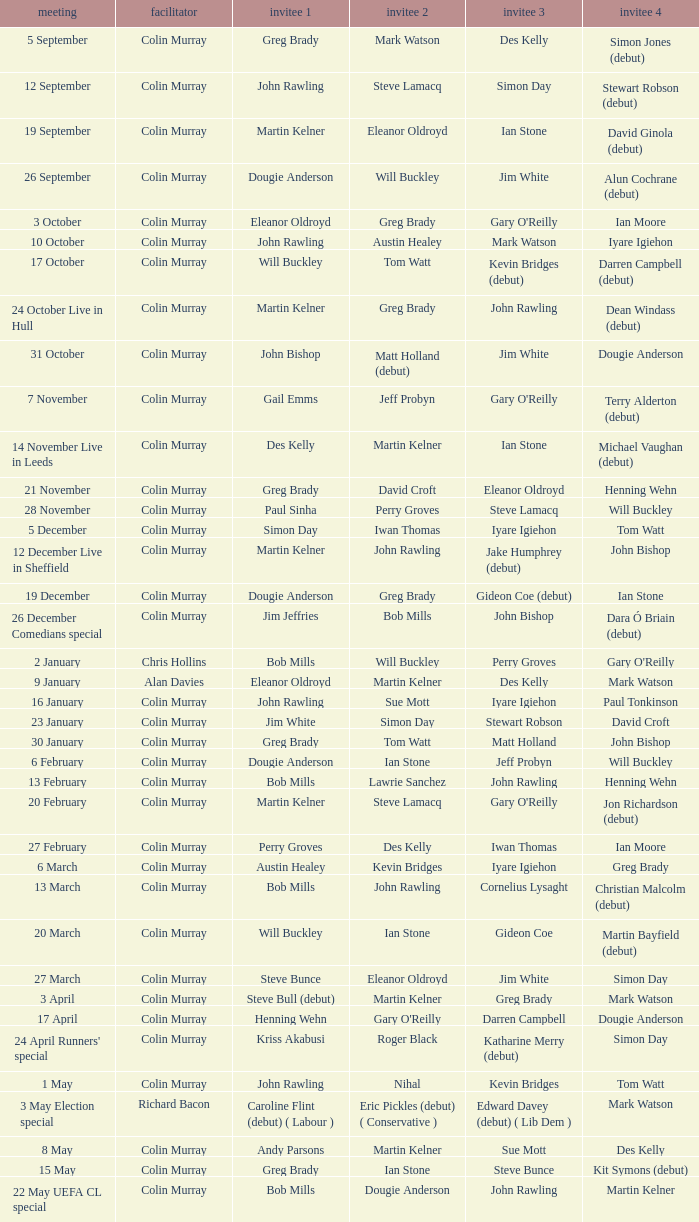Can you give me this table as a dict? {'header': ['meeting', 'facilitator', 'invitee 1', 'invitee 2', 'invitee 3', 'invitee 4'], 'rows': [['5 September', 'Colin Murray', 'Greg Brady', 'Mark Watson', 'Des Kelly', 'Simon Jones (debut)'], ['12 September', 'Colin Murray', 'John Rawling', 'Steve Lamacq', 'Simon Day', 'Stewart Robson (debut)'], ['19 September', 'Colin Murray', 'Martin Kelner', 'Eleanor Oldroyd', 'Ian Stone', 'David Ginola (debut)'], ['26 September', 'Colin Murray', 'Dougie Anderson', 'Will Buckley', 'Jim White', 'Alun Cochrane (debut)'], ['3 October', 'Colin Murray', 'Eleanor Oldroyd', 'Greg Brady', "Gary O'Reilly", 'Ian Moore'], ['10 October', 'Colin Murray', 'John Rawling', 'Austin Healey', 'Mark Watson', 'Iyare Igiehon'], ['17 October', 'Colin Murray', 'Will Buckley', 'Tom Watt', 'Kevin Bridges (debut)', 'Darren Campbell (debut)'], ['24 October Live in Hull', 'Colin Murray', 'Martin Kelner', 'Greg Brady', 'John Rawling', 'Dean Windass (debut)'], ['31 October', 'Colin Murray', 'John Bishop', 'Matt Holland (debut)', 'Jim White', 'Dougie Anderson'], ['7 November', 'Colin Murray', 'Gail Emms', 'Jeff Probyn', "Gary O'Reilly", 'Terry Alderton (debut)'], ['14 November Live in Leeds', 'Colin Murray', 'Des Kelly', 'Martin Kelner', 'Ian Stone', 'Michael Vaughan (debut)'], ['21 November', 'Colin Murray', 'Greg Brady', 'David Croft', 'Eleanor Oldroyd', 'Henning Wehn'], ['28 November', 'Colin Murray', 'Paul Sinha', 'Perry Groves', 'Steve Lamacq', 'Will Buckley'], ['5 December', 'Colin Murray', 'Simon Day', 'Iwan Thomas', 'Iyare Igiehon', 'Tom Watt'], ['12 December Live in Sheffield', 'Colin Murray', 'Martin Kelner', 'John Rawling', 'Jake Humphrey (debut)', 'John Bishop'], ['19 December', 'Colin Murray', 'Dougie Anderson', 'Greg Brady', 'Gideon Coe (debut)', 'Ian Stone'], ['26 December Comedians special', 'Colin Murray', 'Jim Jeffries', 'Bob Mills', 'John Bishop', 'Dara Ó Briain (debut)'], ['2 January', 'Chris Hollins', 'Bob Mills', 'Will Buckley', 'Perry Groves', "Gary O'Reilly"], ['9 January', 'Alan Davies', 'Eleanor Oldroyd', 'Martin Kelner', 'Des Kelly', 'Mark Watson'], ['16 January', 'Colin Murray', 'John Rawling', 'Sue Mott', 'Iyare Igiehon', 'Paul Tonkinson'], ['23 January', 'Colin Murray', 'Jim White', 'Simon Day', 'Stewart Robson', 'David Croft'], ['30 January', 'Colin Murray', 'Greg Brady', 'Tom Watt', 'Matt Holland', 'John Bishop'], ['6 February', 'Colin Murray', 'Dougie Anderson', 'Ian Stone', 'Jeff Probyn', 'Will Buckley'], ['13 February', 'Colin Murray', 'Bob Mills', 'Lawrie Sanchez', 'John Rawling', 'Henning Wehn'], ['20 February', 'Colin Murray', 'Martin Kelner', 'Steve Lamacq', "Gary O'Reilly", 'Jon Richardson (debut)'], ['27 February', 'Colin Murray', 'Perry Groves', 'Des Kelly', 'Iwan Thomas', 'Ian Moore'], ['6 March', 'Colin Murray', 'Austin Healey', 'Kevin Bridges', 'Iyare Igiehon', 'Greg Brady'], ['13 March', 'Colin Murray', 'Bob Mills', 'John Rawling', 'Cornelius Lysaght', 'Christian Malcolm (debut)'], ['20 March', 'Colin Murray', 'Will Buckley', 'Ian Stone', 'Gideon Coe', 'Martin Bayfield (debut)'], ['27 March', 'Colin Murray', 'Steve Bunce', 'Eleanor Oldroyd', 'Jim White', 'Simon Day'], ['3 April', 'Colin Murray', 'Steve Bull (debut)', 'Martin Kelner', 'Greg Brady', 'Mark Watson'], ['17 April', 'Colin Murray', 'Henning Wehn', "Gary O'Reilly", 'Darren Campbell', 'Dougie Anderson'], ["24 April Runners' special", 'Colin Murray', 'Kriss Akabusi', 'Roger Black', 'Katharine Merry (debut)', 'Simon Day'], ['1 May', 'Colin Murray', 'John Rawling', 'Nihal', 'Kevin Bridges', 'Tom Watt'], ['3 May Election special', 'Richard Bacon', 'Caroline Flint (debut) ( Labour )', 'Eric Pickles (debut) ( Conservative )', 'Edward Davey (debut) ( Lib Dem )', 'Mark Watson'], ['8 May', 'Colin Murray', 'Andy Parsons', 'Martin Kelner', 'Sue Mott', 'Des Kelly'], ['15 May', 'Colin Murray', 'Greg Brady', 'Ian Stone', 'Steve Bunce', 'Kit Symons (debut)'], ['22 May UEFA CL special', 'Colin Murray', 'Bob Mills', 'Dougie Anderson', 'John Rawling', 'Martin Kelner']]} On episodes where guest 1 is Jim White, who was guest 3? Stewart Robson. 